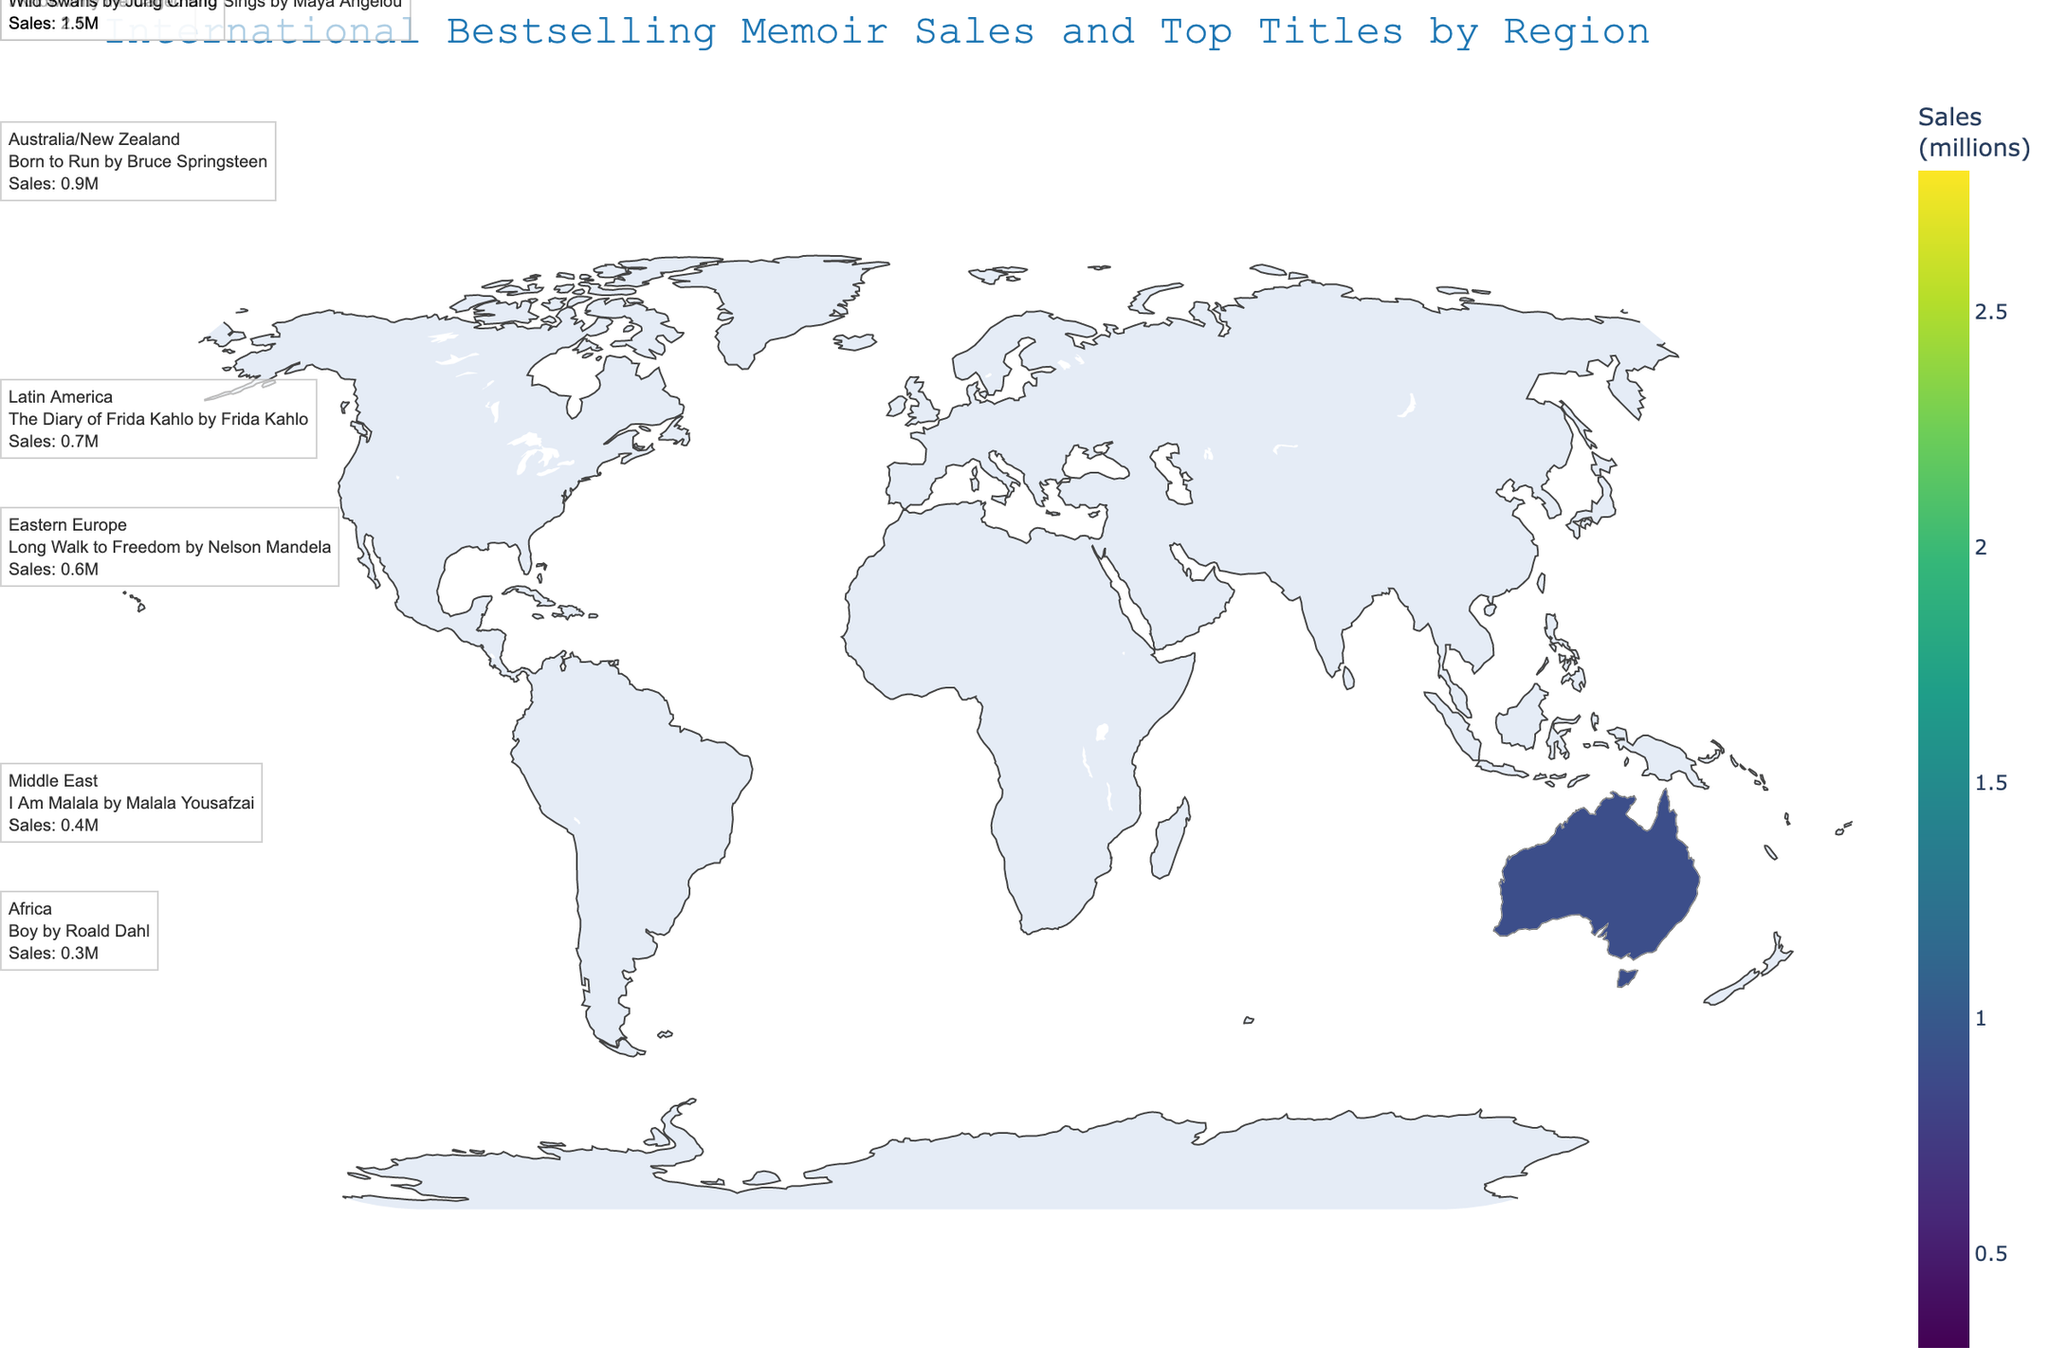what is the title of the plot? The title is located at the top center of the plot. By reading this, we can quickly understand the main subject of the plot.
Answer: International Bestselling Memoir Sales and Top Titles by Region which region has the highest book sales? By examining the color intensity on the choropleth map, North America has the deepest color, indicating the highest book sales. Additionally, the annotation confirms sales in North America.
Answer: North America what is the readership score of bestselling memoirs in Asia? The readership score is presented in the dataset and can also be examined using annotations on the plot. Asia's readership score is 72.
Answer: 72 compare the book sales in Western Europe and Latin America. Which region has higher sales? By inspecting the color gradient on the plotted map and the respective annotations, Western Europe has higher sales than Latin America. Western Europe records 2.1 million sales versus Latin America's 0.7 million.
Answer: Western Europe what is the average book sales across all the regions? To find the average, sum all the sales figures: 2.8 + 2.1 + 1.5 + 0.9 + 0.7 + 0.6 + 0.4 + 0.3 = 9.3 millions, then divide by the number of regions which is 8. Therefore, the average is 9.3 / 8 = 1.1625 million.
Answer: 1.1625 million in which region is "Wild Swans by Jung Chang" the top memoir? By looking at the annotations or the dataset provided, we can see that "Wild Swans by Jung Chang" is the top memoir in Asia.
Answer: Asia how does the readership score in Africa compare to the Middle East? The dataset or annotations indicate that Africa has a readership score of 58, which is slightly below the Middle East's score of 60. This indicates a lower readership score in Africa.
Answer: Africa's score is lower which region has the lowest readership score and what is the top-selling memoir there? From the dataset or annotations, Africa has the lowest readership score of 58 and the top-selling memoir is "Boy by Roald Dahl."
Answer: Africa; "Boy by Roald Dahl" what is the total readership score for all regions combined? To find the total, sum up all the readership scores: 85 + 78 + 72 + 80 + 68 + 65 + 60 + 58 = 566. So, the combined readership score is 566.
Answer: 566 